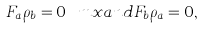<formula> <loc_0><loc_0><loc_500><loc_500>F _ { a } \rho _ { b } = 0 \ m x { a n d } F _ { b } \rho _ { a } = 0 ,</formula> 